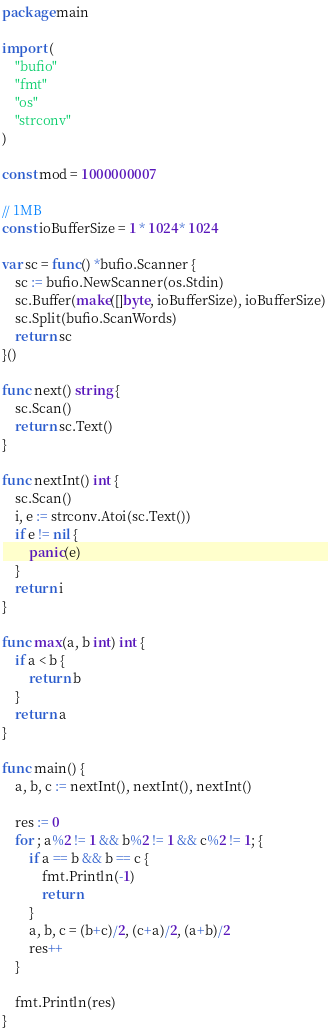<code> <loc_0><loc_0><loc_500><loc_500><_Go_>package main

import (
	"bufio"
	"fmt"
	"os"
	"strconv"
)

const mod = 1000000007

// 1MB
const ioBufferSize = 1 * 1024 * 1024

var sc = func() *bufio.Scanner {
	sc := bufio.NewScanner(os.Stdin)
	sc.Buffer(make([]byte, ioBufferSize), ioBufferSize)
	sc.Split(bufio.ScanWords)
	return sc
}()

func next() string {
	sc.Scan()
	return sc.Text()
}

func nextInt() int {
	sc.Scan()
	i, e := strconv.Atoi(sc.Text())
	if e != nil {
		panic(e)
	}
	return i
}

func max(a, b int) int {
	if a < b {
		return b
	}
	return a
}

func main() {
	a, b, c := nextInt(), nextInt(), nextInt()

	res := 0
	for ; a%2 != 1 && b%2 != 1 && c%2 != 1; {
		if a == b && b == c {
			fmt.Println(-1)
			return
		}
		a, b, c = (b+c)/2, (c+a)/2, (a+b)/2
		res++
	}

	fmt.Println(res)
}
</code> 